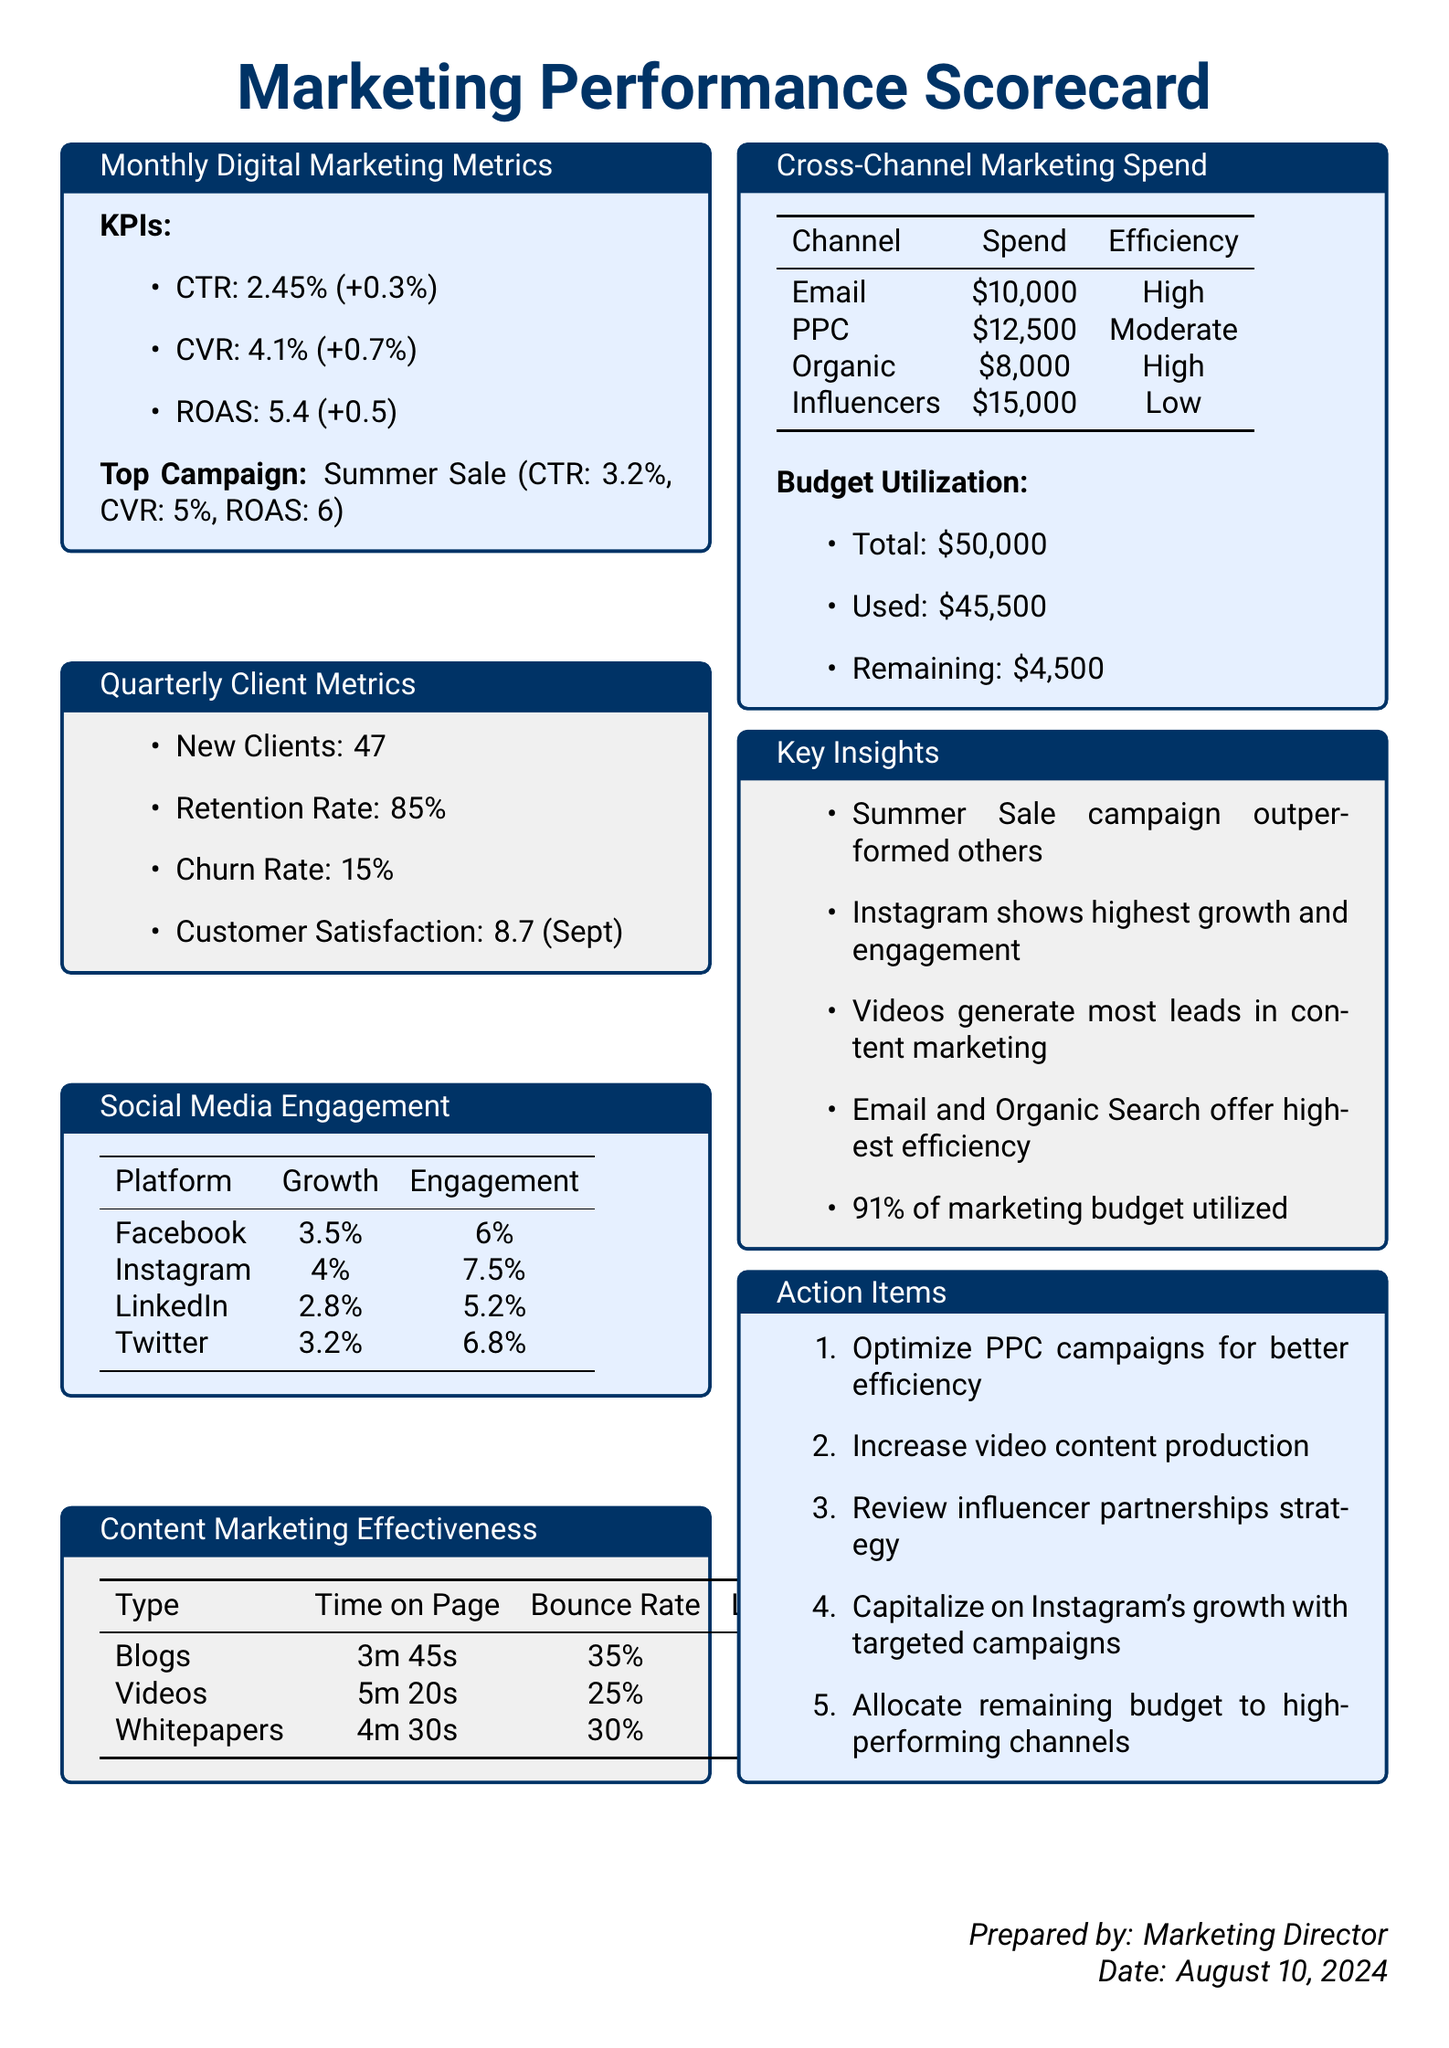what is the CTR for the top campaign? The top campaign, Summer Sale, has a CTR of 3.2%.
Answer: 3.2% how many new clients were acquired quarterly? The document states that 47 new clients were acquired in the quarter.
Answer: 47 what is the bounce rate for blogs? According to the content marketing effectiveness report, the bounce rate for blogs is 35%.
Answer: 35% which platform shows the highest engagement rate? The engagement rate for Instagram is the highest at 7.5%.
Answer: Instagram what is the retention rate of existing clients? The retention rate for existing clients is listed as 85%.
Answer: 85% how much was spent on influencer marketing? The document indicates that $15,000 was spent on influencer marketing.
Answer: $15,000 what is the average customer satisfaction score? The average customer satisfaction score reported for September is 8.7.
Answer: 8.7 which type of content generates the most leads? The effectiveness report shows that videos generate the most leads.
Answer: Videos what percentage of the marketing budget was utilized? The document states that 91% of the marketing budget was utilized.
Answer: 91% what action item focuses on Instagram? The action item to capitalize on Instagram's growth with targeted campaigns addresses this.
Answer: Targeted campaigns 